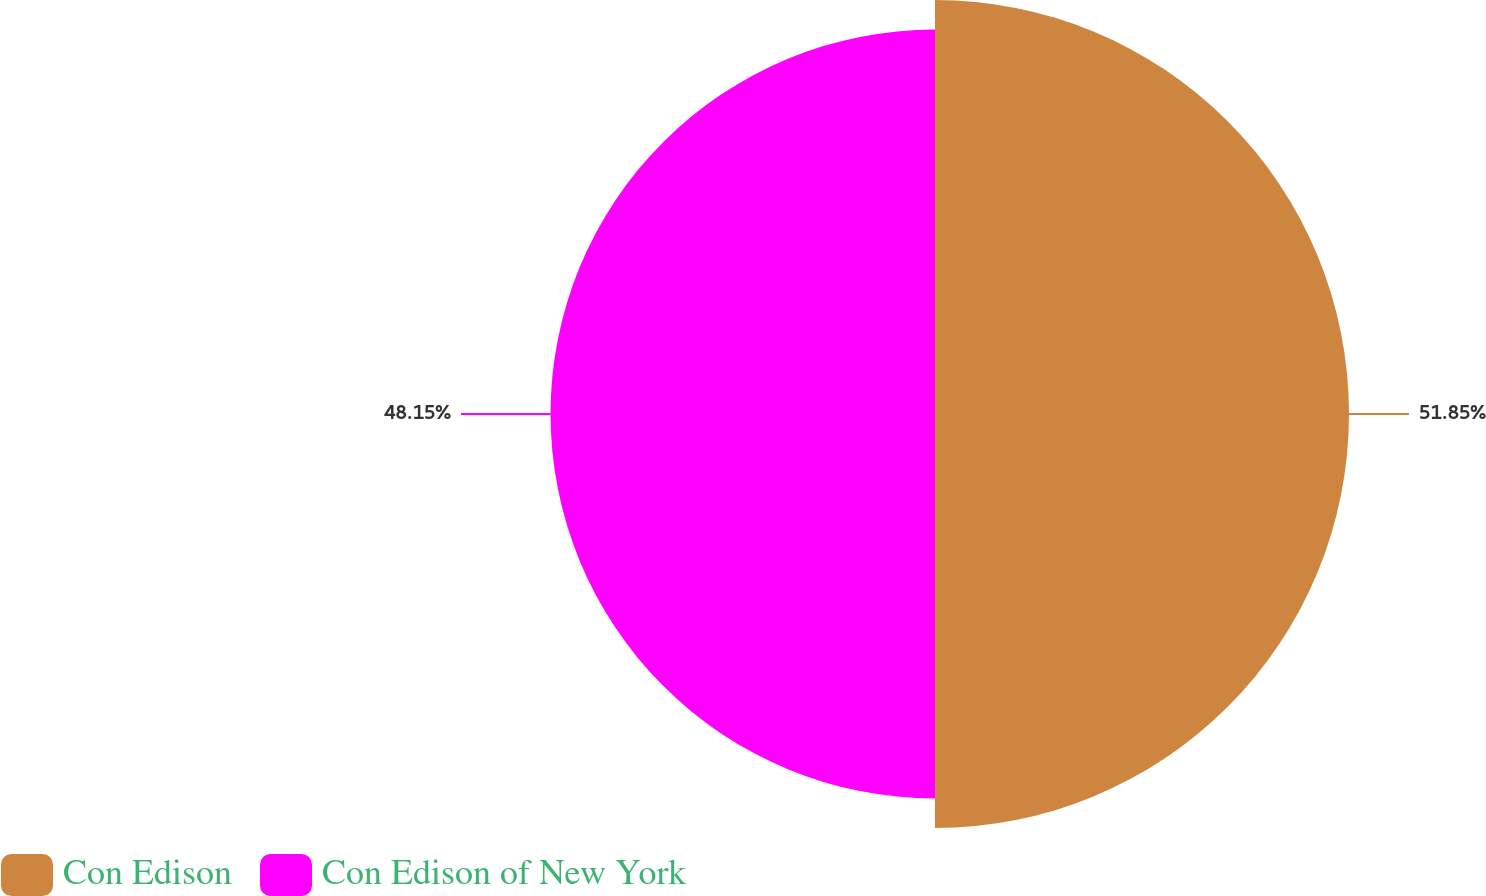Convert chart. <chart><loc_0><loc_0><loc_500><loc_500><pie_chart><fcel>Con Edison<fcel>Con Edison of New York<nl><fcel>51.85%<fcel>48.15%<nl></chart> 